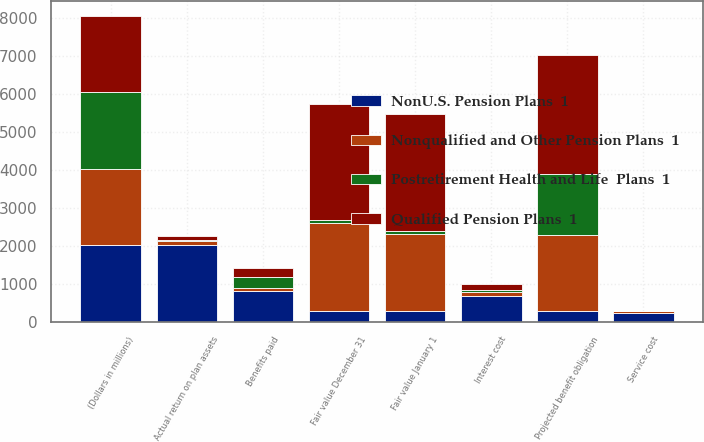Convert chart to OTSL. <chart><loc_0><loc_0><loc_500><loc_500><stacked_bar_chart><ecel><fcel>(Dollars in millions)<fcel>Fair value January 1<fcel>Actual return on plan assets<fcel>Benefits paid<fcel>Fair value December 31<fcel>Projected benefit obligation<fcel>Service cost<fcel>Interest cost<nl><fcel>NonU.S. Pension Plans  1<fcel>2012<fcel>290<fcel>2020<fcel>816<fcel>290<fcel>290<fcel>236<fcel>681<nl><fcel>Nonqualified and Other Pension Plans  1<fcel>2012<fcel>2022<fcel>115<fcel>77<fcel>2306<fcel>1984<fcel>40<fcel>97<nl><fcel>Qualified Pension Plans  1<fcel>2012<fcel>3061<fcel>126<fcel>236<fcel>3063<fcel>3137<fcel>1<fcel>138<nl><fcel>Postretirement Health and Life  Plans  1<fcel>2012<fcel>91<fcel>10<fcel>290<fcel>86<fcel>1619<fcel>13<fcel>71<nl></chart> 